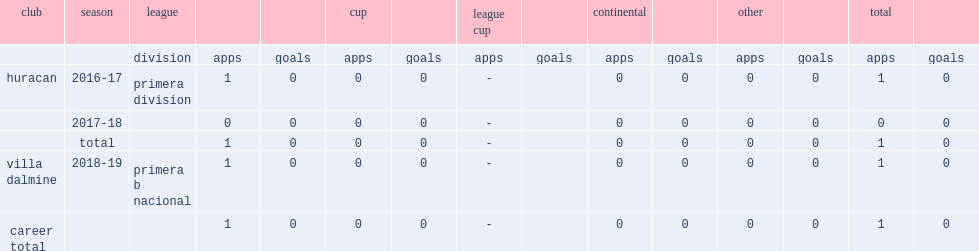Which league did cuevas participate in the 2016-17 season for huracan? Primera division. 